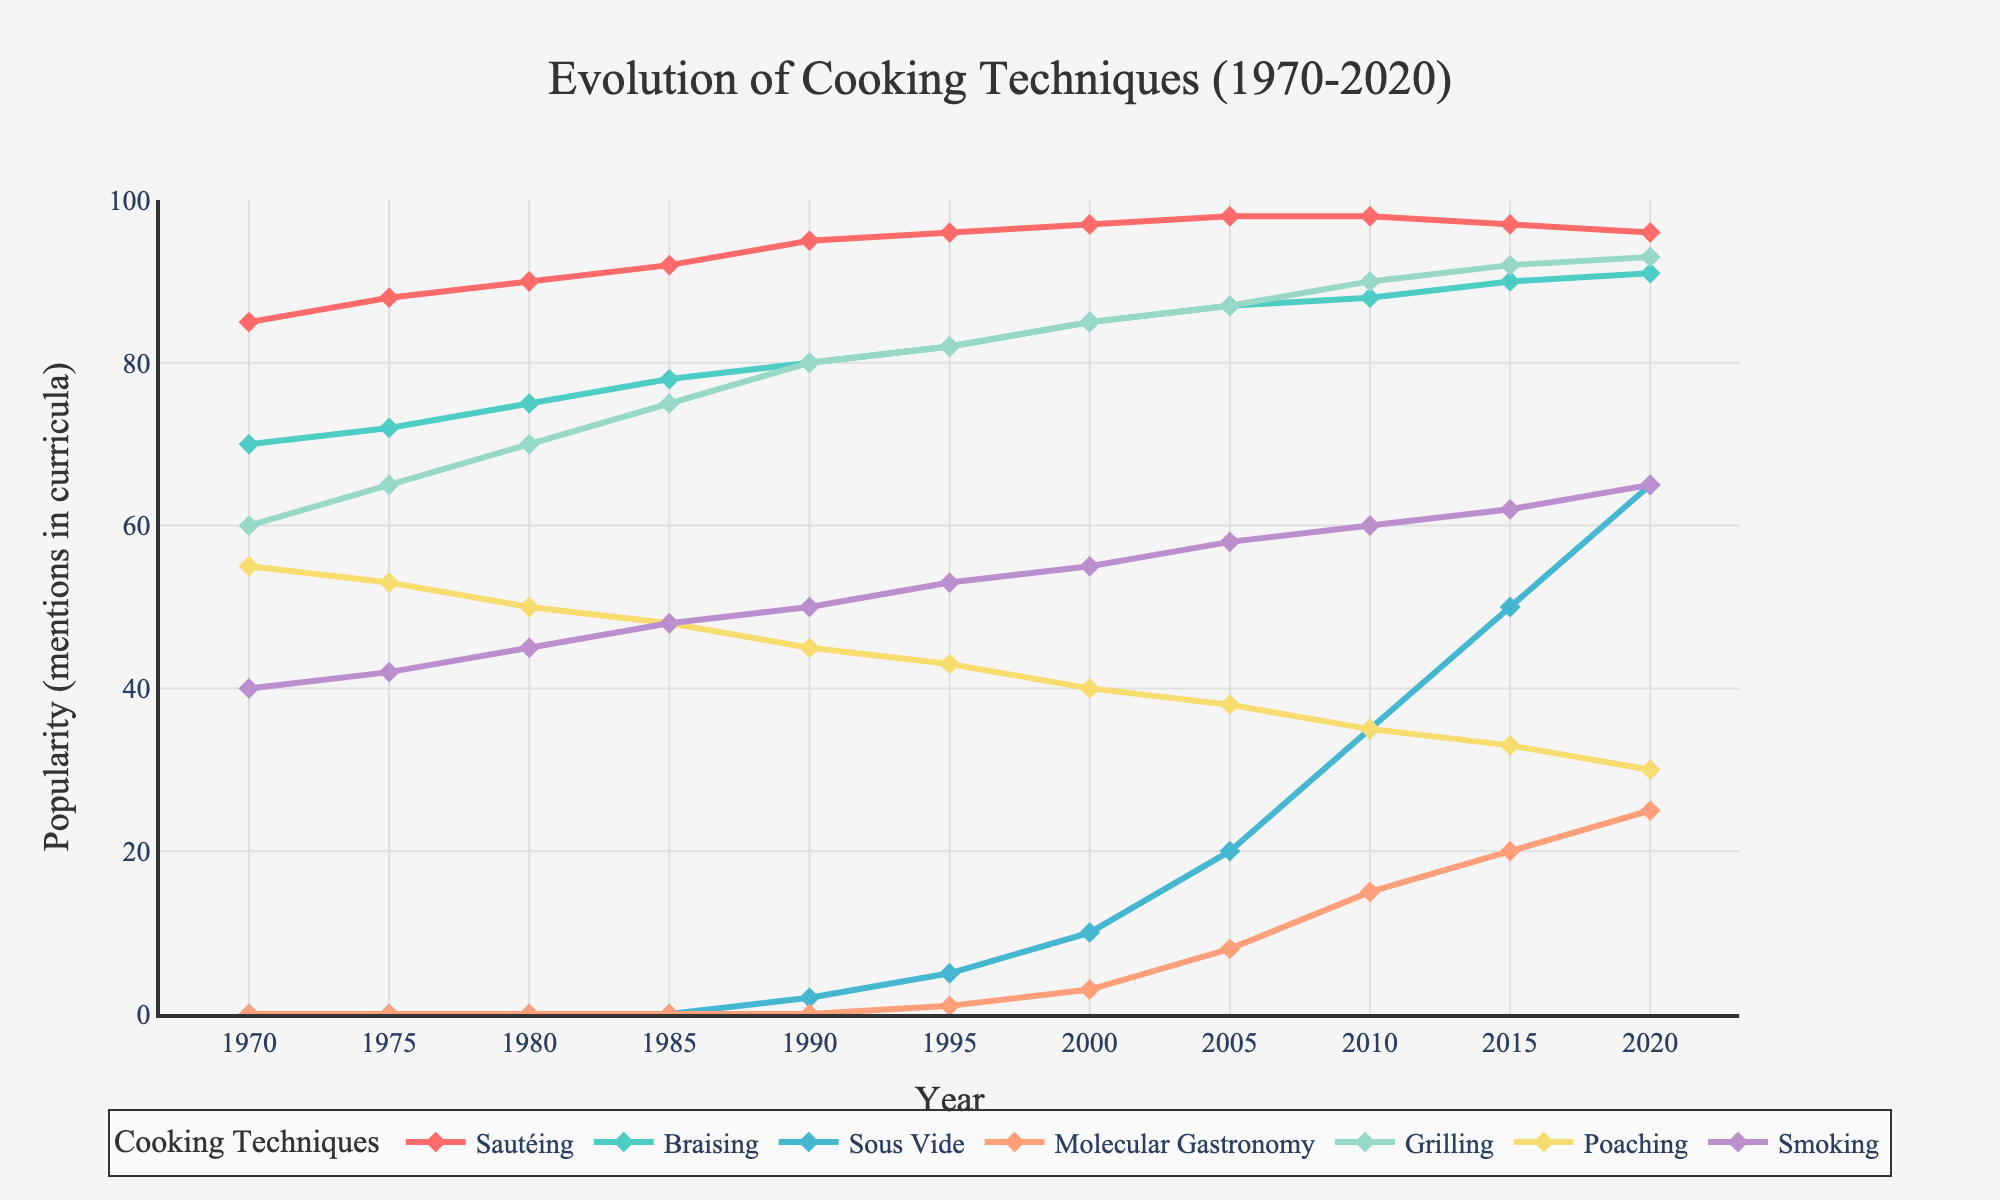**Question 1:** Which cooking technique saw the largest increase in popularity from 1970 to 2020? Explanation: To determine the technique with the largest increase, subtract the popularity value in 1970 from that in 2020 for each technique. Sautéing: 96 - 85 = 11, Braising: 91 - 70 = 21, Sous Vide: 65 - 0 = 65, Molecular Gastronomy: 25 - 0 = 25, Grilling: 93 - 60 = 33, Poaching: 30 - 55 = -25, Smoking: 65 - 40 = 25. The largest increase is for "Sous Vide" with 65.
Answer: Sous Vide **Question 2:** During which decade did Grilling see the most significant rise in popularity? Explanation: Track the Grilling values across the decades: 1970s (65-60=5), 1980s (75-65=10), 1990s (82-75=7), 2000s (87-82=5), 2010s (90-87=3). The largest increase occurs in the 1980s with an increase of 10.
Answer: 1980s **Question 3:** At what year did Smoking surpass Poaching in popularity? Explanation: Identify the year Poaching falls below Smoking. Compare values year by year. In 2000, Poaching is at 40 and Smoking at 55. In 2005, Poaching is at 38 and Smoking is at 58. The year Smoking first surpasses Poaching is 2000.
Answer: 2000 **Question 4:** Which two cooking techniques have their popularity most closely aligned in 2020? Explanation: Compare the values for 2020 to find the closest pair. Differences are: Sautéing (96), Braising (91), Sous Vide (65), Molecular Gastronomy (25), Grilling (93), Poaching (30), Smoking (65). The closest pair is "Sous Vide" and "Smoking" both at 65.
Answer: Sous Vide and Smoking **Question 5:** What is the average popularity of Molecular Gastronomy over the period from 2000 to 2020? Explanation: Calculate the average over the years 2000, 2005, 2010, 2015, and 2020. Values: 3, 8, 15, 20, and 25. Sum is 71. Average is 71/5 = 14.2.
Answer: 14.2 **Question 6:** How many times did the popularity of Sautéing decrease over the 50-year span? Explanation: Identify the years where the value of Sautéing is lower than the previous year. Decreases occur: 2015 to 2020 (97 to 96). This happens once.
Answer: 1 **Question 7:** Which technique had no mentions in culinary school curricula in 1970 but gained notable popularity by 2020? Explanation: Identify techniques with 0 in 1970, and have a higher value in 2020. Sous Vide (0 to 65) and Molecular Gastronomy (0 to 25).
Answer: Sous Vide and Molecular Gastronomy **Question 8:** Across all techniques, what is the steepest single-year increase seen from 2005 to 2020? Explanation: Calculate year-to-year increases for each technique, identifying the maximum for each. The steepest increase is for Sous Vide from 2005 (20) to 2010 (35), a rise of 15.
Answer: Sous Vide 2005-2010 **Question 9:** When do Sautéing and Grilling both appear at their peak popularity simultaneously? Explanation: Compare the values over the years to identify when both are highest. Both are at their peaks around 2005 (Sautéing 98 and Grilling 87).
Answer: 2005 